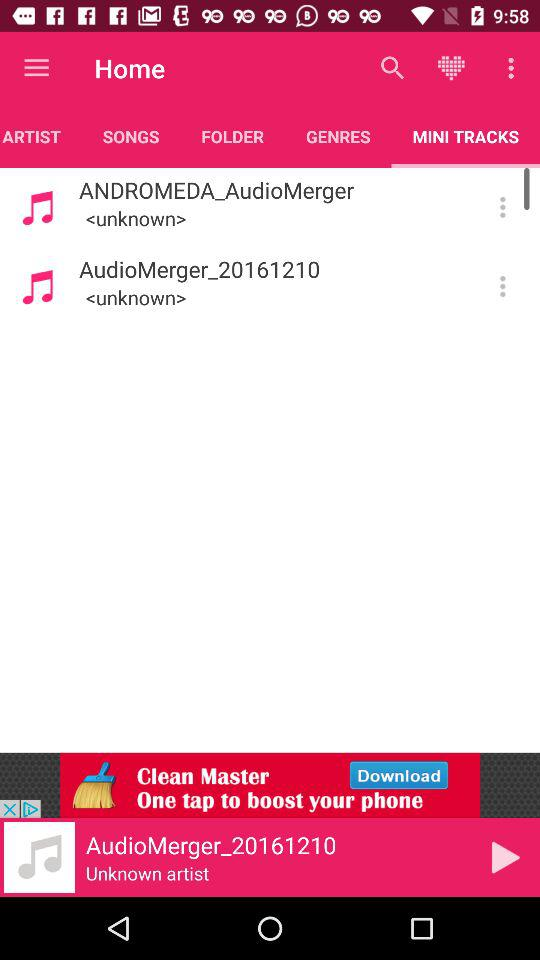How long is "AudioMerger_20161210"?
When the provided information is insufficient, respond with <no answer>. <no answer> 